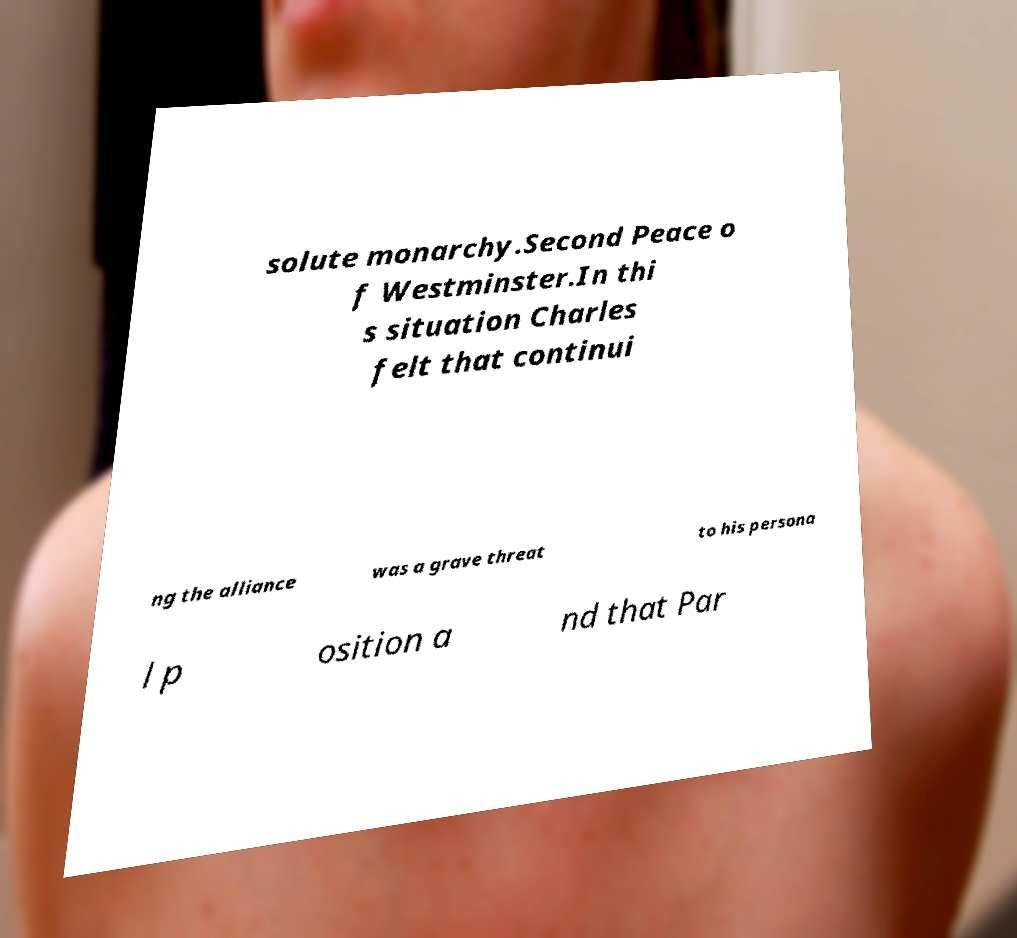I need the written content from this picture converted into text. Can you do that? solute monarchy.Second Peace o f Westminster.In thi s situation Charles felt that continui ng the alliance was a grave threat to his persona l p osition a nd that Par 